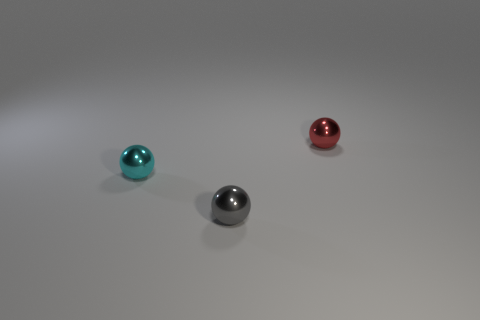Add 2 big blue matte things. How many objects exist? 5 Subtract 1 cyan spheres. How many objects are left? 2 Subtract all small cyan metallic things. Subtract all gray objects. How many objects are left? 1 Add 1 small cyan balls. How many small cyan balls are left? 2 Add 2 large gray things. How many large gray things exist? 2 